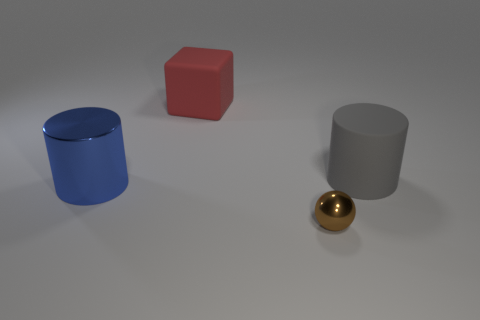Are there more cubes that are in front of the big gray matte cylinder than big cyan rubber blocks?
Keep it short and to the point. No. Are there any other things that are the same material as the tiny brown sphere?
Your answer should be compact. Yes. There is a big cylinder left of the large gray rubber thing; is it the same color as the rubber thing on the left side of the big gray rubber cylinder?
Your answer should be very brief. No. What is the material of the big thing in front of the rubber object in front of the large thing behind the large gray matte thing?
Keep it short and to the point. Metal. Are there more blue metal spheres than big blue metallic objects?
Give a very brief answer. No. Is there any other thing that has the same color as the metallic ball?
Ensure brevity in your answer.  No. What is the size of the gray thing that is made of the same material as the block?
Keep it short and to the point. Large. What is the material of the tiny object?
Offer a very short reply. Metal. How many rubber blocks have the same size as the gray matte object?
Your response must be concise. 1. Are there any tiny brown shiny things that have the same shape as the big gray object?
Offer a terse response. No. 